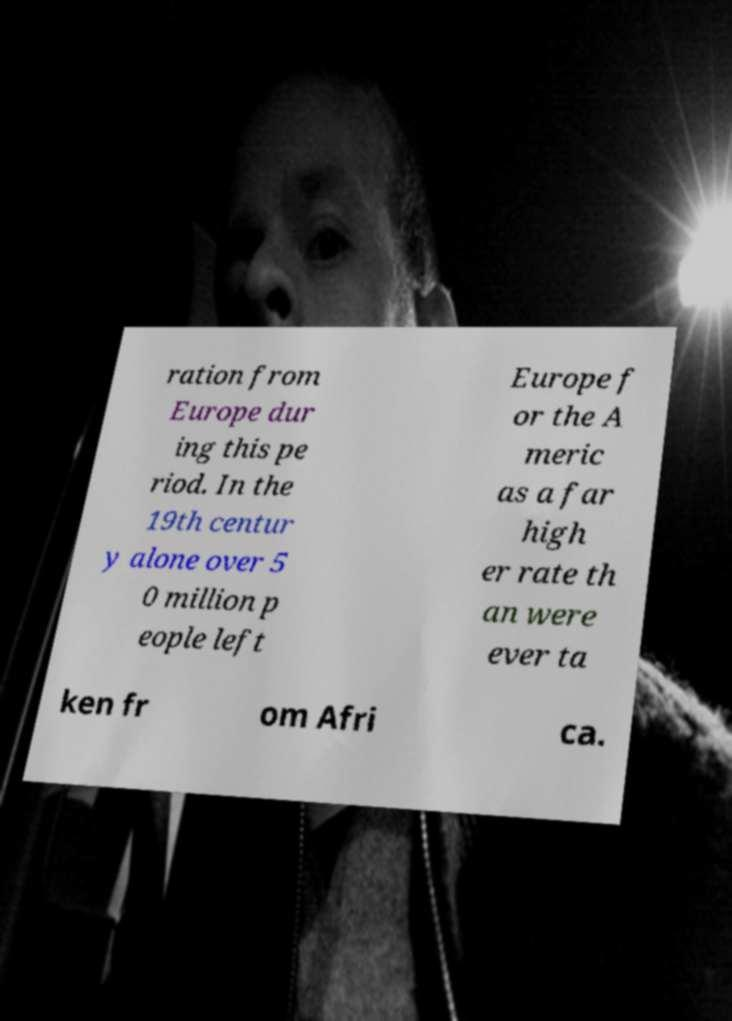Could you extract and type out the text from this image? ration from Europe dur ing this pe riod. In the 19th centur y alone over 5 0 million p eople left Europe f or the A meric as a far high er rate th an were ever ta ken fr om Afri ca. 